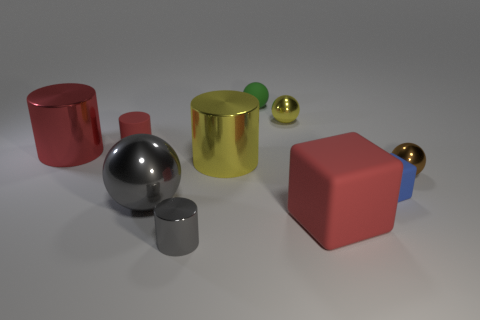What number of other objects are there of the same color as the small rubber cylinder?
Offer a very short reply. 2. Are there more large cylinders than big rubber blocks?
Ensure brevity in your answer.  Yes. How many other things are the same material as the blue cube?
Give a very brief answer. 3. There is a big object on the right side of the tiny metal sphere that is on the left side of the large red block; what number of brown balls are behind it?
Give a very brief answer. 1. How many shiny objects are either blocks or large cyan objects?
Your answer should be very brief. 0. There is a gray metal thing that is in front of the red rubber thing that is right of the tiny gray thing; what is its size?
Offer a very short reply. Small. There is a large cylinder that is left of the large yellow metallic thing; does it have the same color as the ball that is right of the yellow sphere?
Provide a succinct answer. No. What is the color of the big object that is left of the small metallic cylinder and behind the brown shiny sphere?
Your response must be concise. Red. Are the big yellow cylinder and the green ball made of the same material?
Provide a succinct answer. No. What number of tiny things are either purple matte blocks or red matte things?
Make the answer very short. 1. 